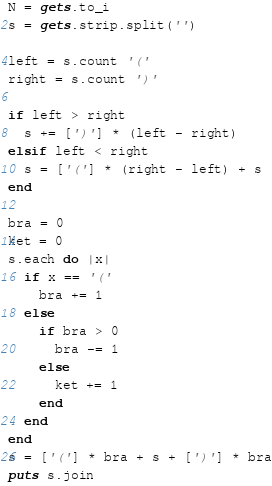<code> <loc_0><loc_0><loc_500><loc_500><_Ruby_>N = gets.to_i
s = gets.strip.split('')

left = s.count '('
right = s.count ')'

if left > right
  s += [')'] * (left - right)
elsif left < right
  s = ['('] * (right - left) + s
end

bra = 0
ket = 0
s.each do |x|
  if x == '('
    bra += 1
  else
    if bra > 0
      bra -= 1
    else
      ket += 1
    end
  end
end
s = ['('] * bra + s + [')'] * bra
puts s.join</code> 